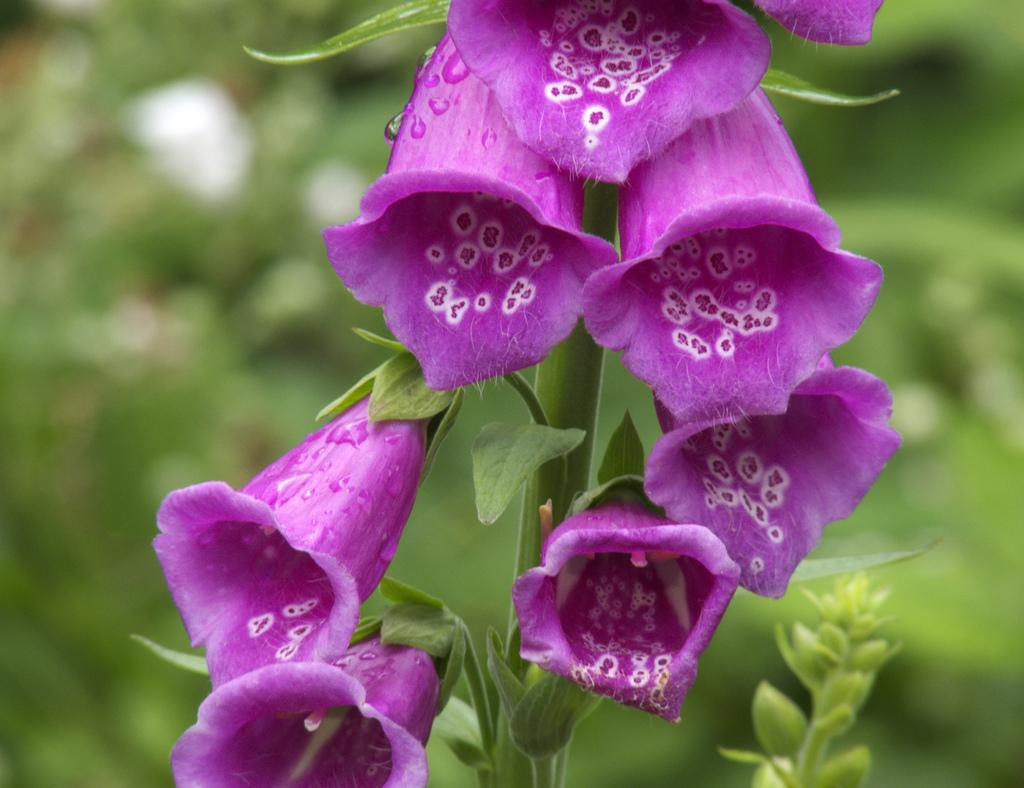What type of plant is visible in the image? There is a plant in the image. What specific features can be observed on the plant? The plant has flowers, and the flowers are violet in color. Are there any other parts of the plant visible in the image? Yes, there are leaves on the plant. Can you describe the background of the image? The background of the image appears blurry. How does the visitor interact with the plant in the image? There is no visitor present in the image, so it is not possible to describe any interaction with the plant. 